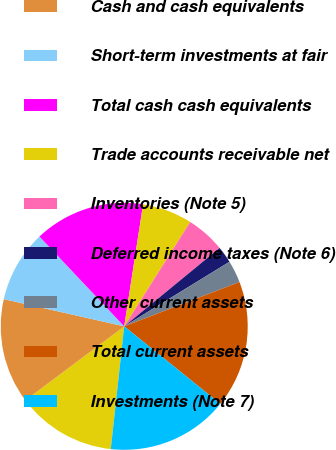<chart> <loc_0><loc_0><loc_500><loc_500><pie_chart><fcel>(In millions except share and<fcel>Cash and cash equivalents<fcel>Short-term investments at fair<fcel>Total cash cash equivalents<fcel>Trade accounts receivable net<fcel>Inventories (Note 5)<fcel>Deferred income taxes (Note 6)<fcel>Other current assets<fcel>Total current assets<fcel>Investments (Note 7)<nl><fcel>13.04%<fcel>13.76%<fcel>9.42%<fcel>14.48%<fcel>6.53%<fcel>5.08%<fcel>2.19%<fcel>2.91%<fcel>16.65%<fcel>15.93%<nl></chart> 